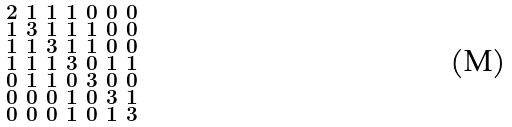<formula> <loc_0><loc_0><loc_500><loc_500>\begin{smallmatrix} 2 & 1 & 1 & 1 & 0 & 0 & 0 \\ 1 & 3 & 1 & 1 & 1 & 0 & 0 \\ 1 & 1 & 3 & 1 & 1 & 0 & 0 \\ 1 & 1 & 1 & 3 & 0 & 1 & 1 \\ 0 & 1 & 1 & 0 & 3 & 0 & 0 \\ 0 & 0 & 0 & 1 & 0 & 3 & 1 \\ 0 & 0 & 0 & 1 & 0 & 1 & 3 \end{smallmatrix}</formula> 